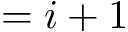<formula> <loc_0><loc_0><loc_500><loc_500>= i + 1</formula> 